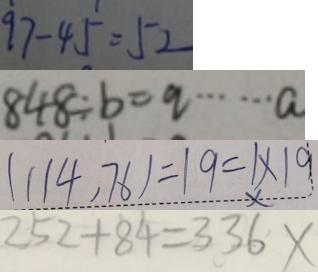Convert formula to latex. <formula><loc_0><loc_0><loc_500><loc_500>9 7 - 4 5 = 5 2 
 8 4 8 \div b = q \cdots a 
 ( 1 1 4 , 7 6 ) = 1 9 = 1 \times 1 9 
 2 5 2 + 8 4 = 3 3 6 x</formula> 